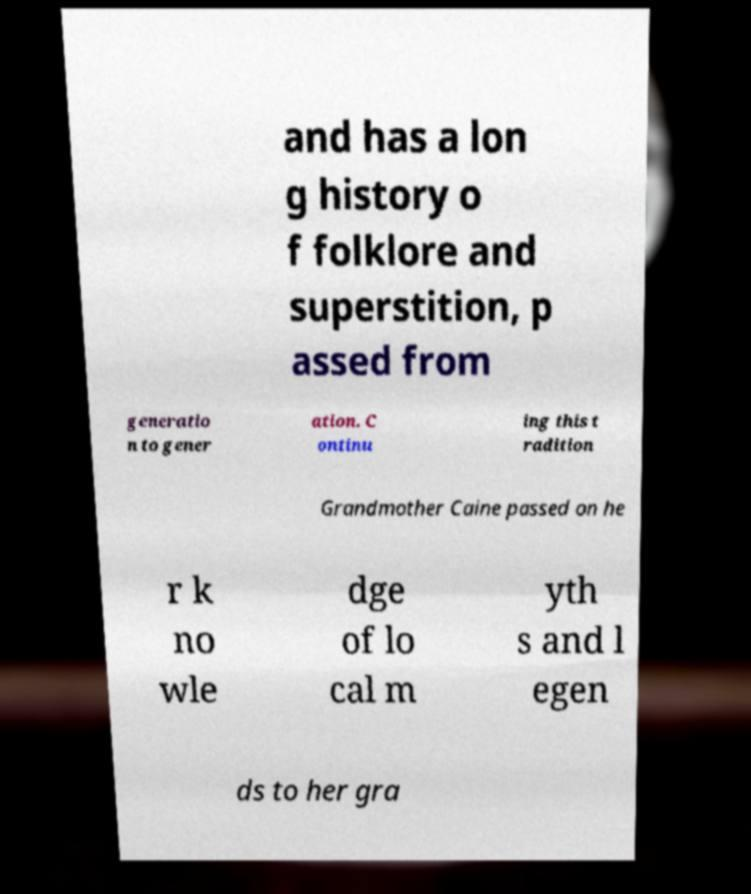Please identify and transcribe the text found in this image. and has a lon g history o f folklore and superstition, p assed from generatio n to gener ation. C ontinu ing this t radition Grandmother Caine passed on he r k no wle dge of lo cal m yth s and l egen ds to her gra 